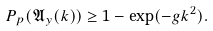Convert formula to latex. <formula><loc_0><loc_0><loc_500><loc_500>P _ { p } ( \mathfrak { A } _ { y } ( k ) ) \geq 1 - \exp ( - g k ^ { 2 } ) .</formula> 